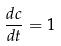<formula> <loc_0><loc_0><loc_500><loc_500>\frac { d c } { d t } = 1</formula> 